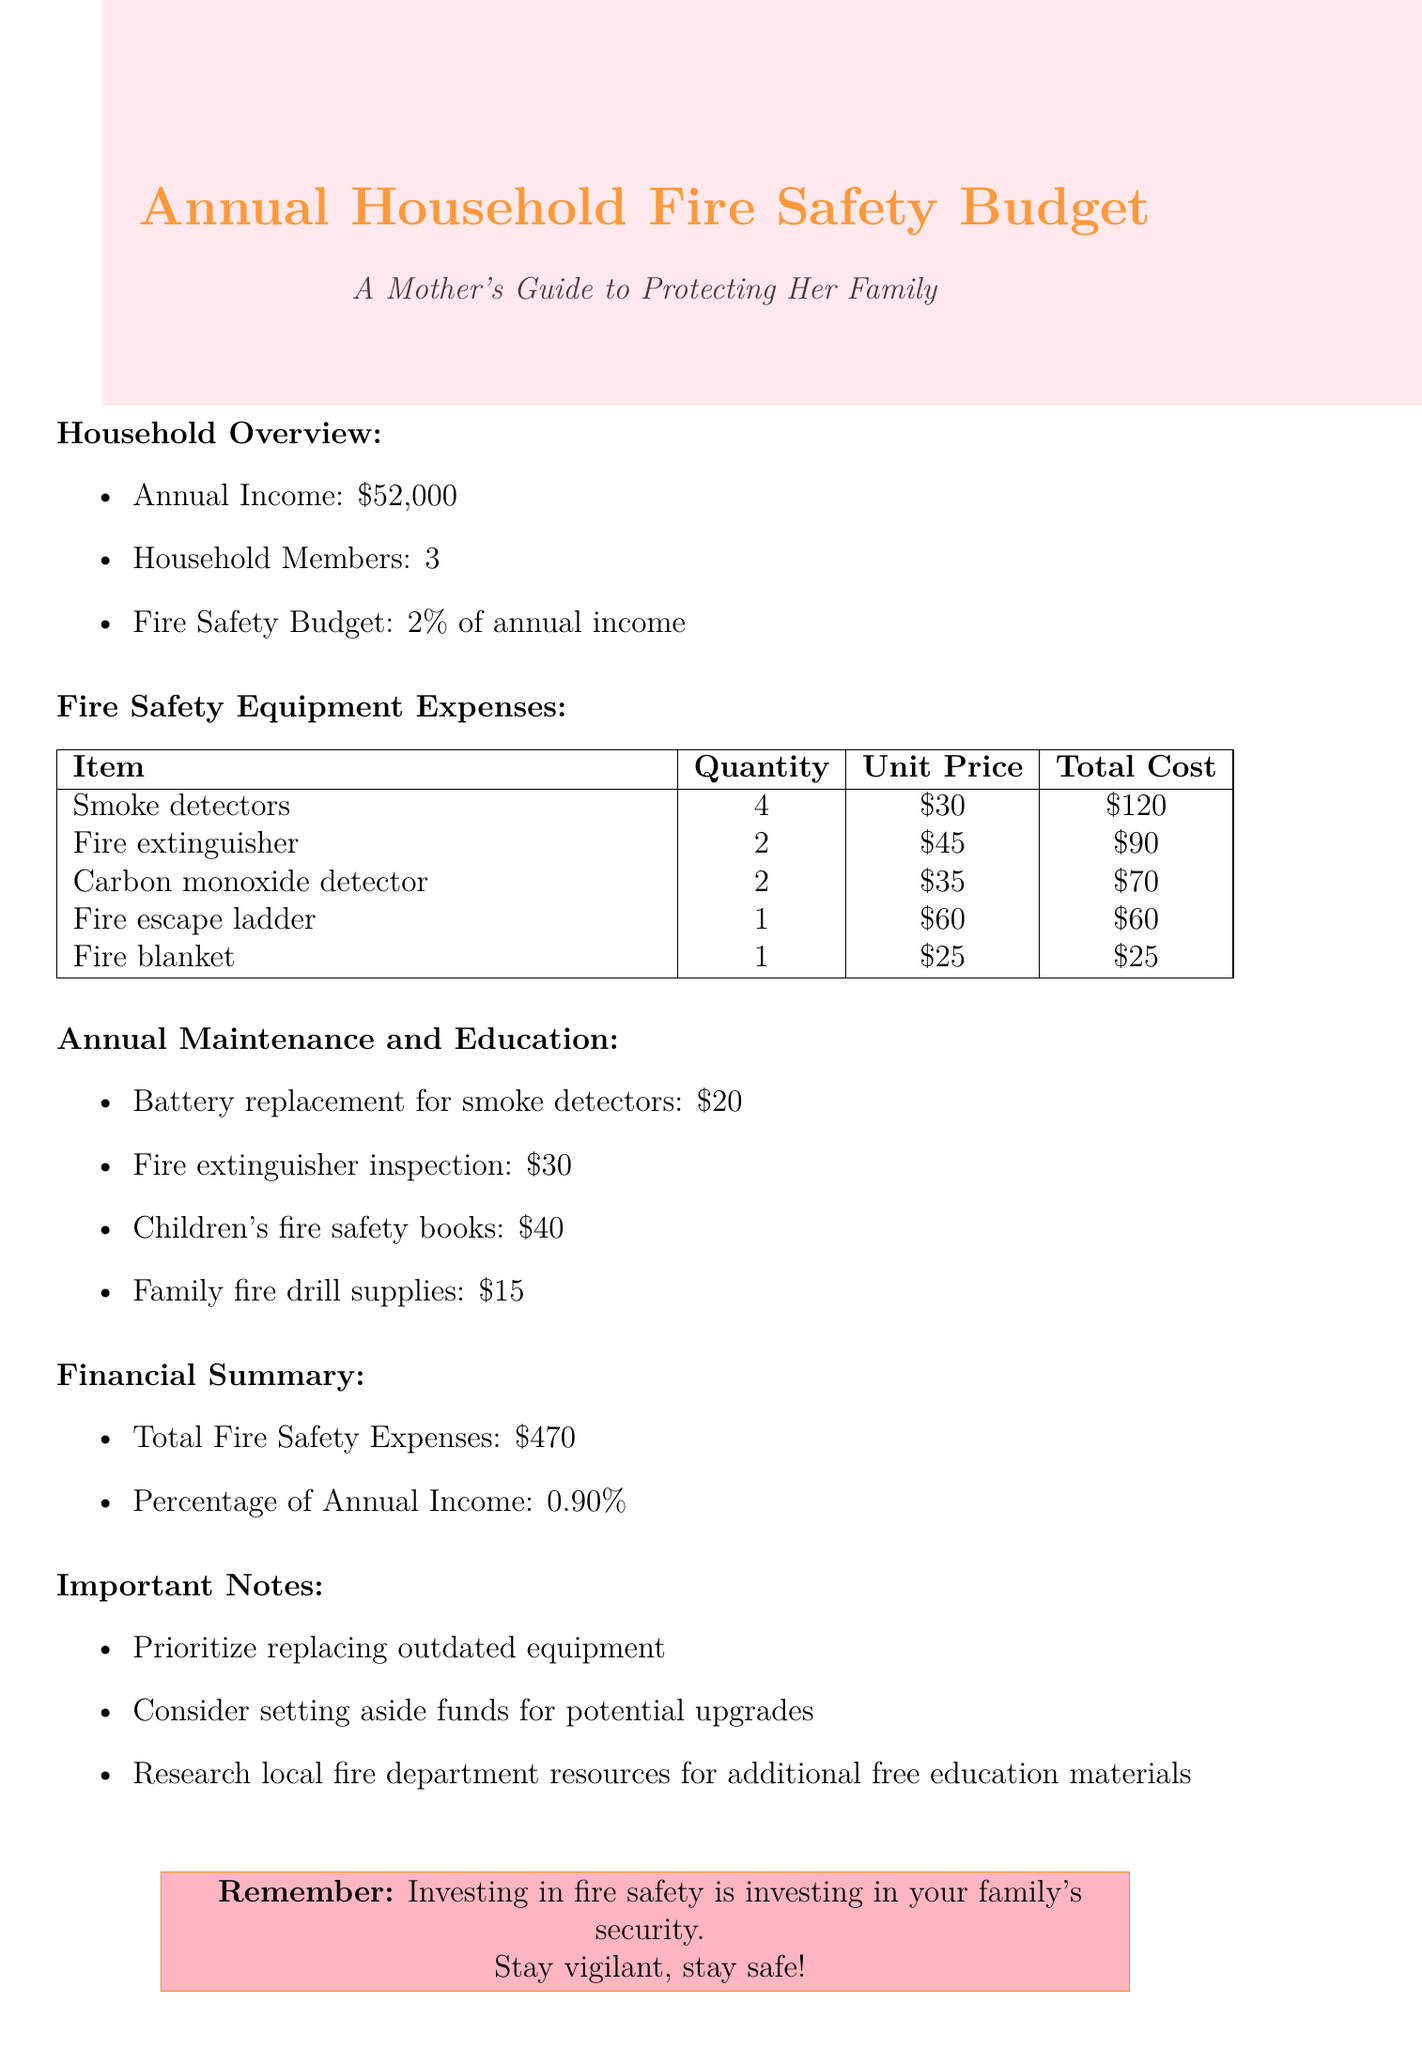What is the annual income of the household? The annual income is specified in the document as $52,000.
Answer: $52,000 How many smoke detectors were purchased? The document lists the quantity of smoke detectors purchased as 4.
Answer: 4 What is the total cost of the fire extinguishers? The total cost of the fire extinguishers is calculated in the document as $90.
Answer: $90 What percentage of the annual income is allocated to fire safety? The percentage allocated to fire safety is stated as 2% of the annual income.
Answer: 2% What is the annual cost for battery replacement? The annual cost for battery replacement for smoke detectors is $20 according to the document.
Answer: $20 What is the total fire safety expense? The total fire safety expenses summarized in the document is $470.
Answer: $470 What item has an annual cost of $15? The document identifies the family fire drill supplies as having an annual cost of $15.
Answer: Family fire drill supplies What does the document recommend prioritizing? The document recommends prioritizing the replacement of outdated equipment.
Answer: Replacing outdated equipment How many household members are there? The number of household members is listed as 3 in the document.
Answer: 3 